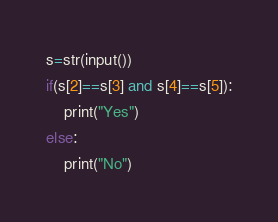Convert code to text. <code><loc_0><loc_0><loc_500><loc_500><_Python_>s=str(input())
if(s[2]==s[3] and s[4]==s[5]):
	print("Yes")
else:
	print("No")</code> 